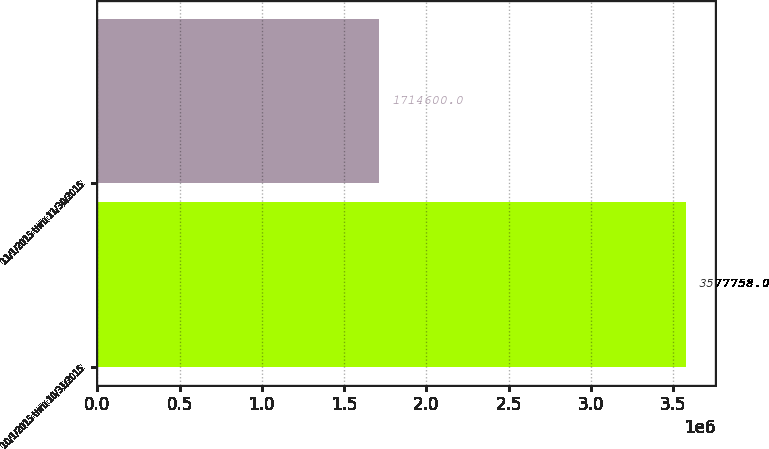Convert chart to OTSL. <chart><loc_0><loc_0><loc_500><loc_500><bar_chart><fcel>10/1/2015 thru 10/31/2015<fcel>11/1/2015 thru 11/30/2015<nl><fcel>3.57776e+06<fcel>1.7146e+06<nl></chart> 